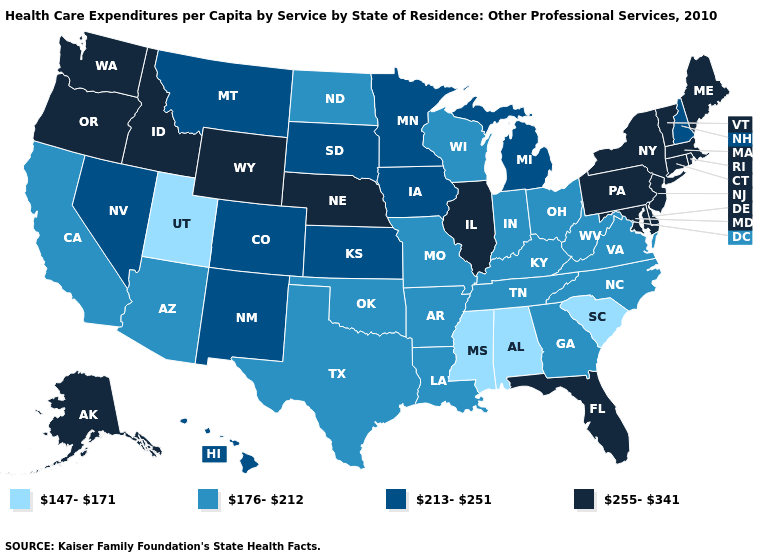What is the lowest value in the USA?
Be succinct. 147-171. What is the value of Alaska?
Be succinct. 255-341. What is the highest value in states that border Missouri?
Answer briefly. 255-341. What is the value of Connecticut?
Give a very brief answer. 255-341. Does South Carolina have a lower value than Alabama?
Write a very short answer. No. What is the value of Montana?
Give a very brief answer. 213-251. What is the value of Kentucky?
Write a very short answer. 176-212. Name the states that have a value in the range 147-171?
Concise answer only. Alabama, Mississippi, South Carolina, Utah. What is the highest value in the Northeast ?
Short answer required. 255-341. Does the map have missing data?
Be succinct. No. Name the states that have a value in the range 147-171?
Be succinct. Alabama, Mississippi, South Carolina, Utah. What is the value of Nevada?
Quick response, please. 213-251. Name the states that have a value in the range 213-251?
Answer briefly. Colorado, Hawaii, Iowa, Kansas, Michigan, Minnesota, Montana, Nevada, New Hampshire, New Mexico, South Dakota. Does Alaska have the same value as New Jersey?
Write a very short answer. Yes. 